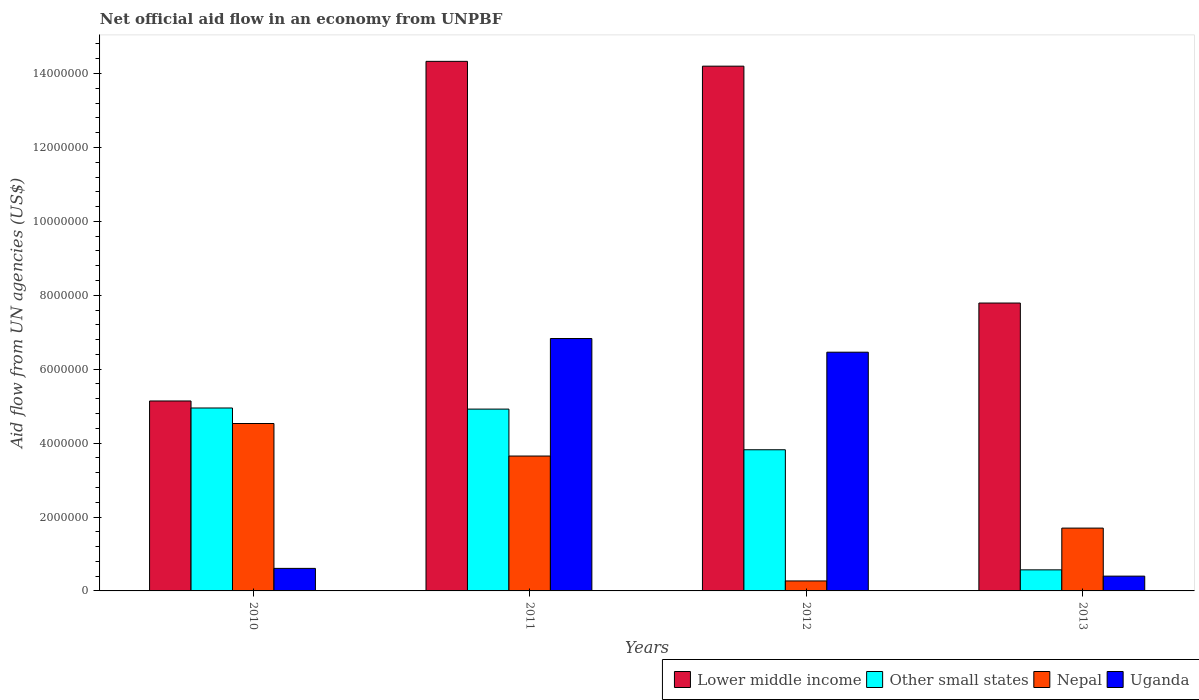How many different coloured bars are there?
Give a very brief answer. 4. How many bars are there on the 1st tick from the right?
Your answer should be very brief. 4. What is the label of the 3rd group of bars from the left?
Make the answer very short. 2012. In how many cases, is the number of bars for a given year not equal to the number of legend labels?
Provide a succinct answer. 0. What is the net official aid flow in Lower middle income in 2010?
Your response must be concise. 5.14e+06. Across all years, what is the maximum net official aid flow in Nepal?
Offer a very short reply. 4.53e+06. In which year was the net official aid flow in Lower middle income maximum?
Give a very brief answer. 2011. In which year was the net official aid flow in Other small states minimum?
Provide a succinct answer. 2013. What is the total net official aid flow in Other small states in the graph?
Provide a succinct answer. 1.43e+07. What is the difference between the net official aid flow in Nepal in 2011 and that in 2012?
Your answer should be very brief. 3.38e+06. What is the average net official aid flow in Uganda per year?
Provide a short and direct response. 3.58e+06. In the year 2011, what is the difference between the net official aid flow in Lower middle income and net official aid flow in Nepal?
Provide a short and direct response. 1.07e+07. In how many years, is the net official aid flow in Other small states greater than 7200000 US$?
Offer a terse response. 0. What is the ratio of the net official aid flow in Lower middle income in 2010 to that in 2012?
Give a very brief answer. 0.36. What is the difference between the highest and the second highest net official aid flow in Other small states?
Ensure brevity in your answer.  3.00e+04. What is the difference between the highest and the lowest net official aid flow in Uganda?
Your answer should be very brief. 6.43e+06. Is it the case that in every year, the sum of the net official aid flow in Lower middle income and net official aid flow in Uganda is greater than the sum of net official aid flow in Other small states and net official aid flow in Nepal?
Offer a terse response. Yes. What does the 2nd bar from the left in 2012 represents?
Your response must be concise. Other small states. What does the 3rd bar from the right in 2013 represents?
Give a very brief answer. Other small states. Is it the case that in every year, the sum of the net official aid flow in Nepal and net official aid flow in Uganda is greater than the net official aid flow in Other small states?
Your answer should be very brief. Yes. Are the values on the major ticks of Y-axis written in scientific E-notation?
Make the answer very short. No. Does the graph contain grids?
Offer a terse response. No. Where does the legend appear in the graph?
Keep it short and to the point. Bottom right. How many legend labels are there?
Provide a succinct answer. 4. What is the title of the graph?
Ensure brevity in your answer.  Net official aid flow in an economy from UNPBF. Does "Somalia" appear as one of the legend labels in the graph?
Provide a succinct answer. No. What is the label or title of the X-axis?
Your answer should be compact. Years. What is the label or title of the Y-axis?
Your answer should be compact. Aid flow from UN agencies (US$). What is the Aid flow from UN agencies (US$) of Lower middle income in 2010?
Offer a very short reply. 5.14e+06. What is the Aid flow from UN agencies (US$) in Other small states in 2010?
Ensure brevity in your answer.  4.95e+06. What is the Aid flow from UN agencies (US$) of Nepal in 2010?
Your answer should be very brief. 4.53e+06. What is the Aid flow from UN agencies (US$) of Lower middle income in 2011?
Offer a terse response. 1.43e+07. What is the Aid flow from UN agencies (US$) in Other small states in 2011?
Your answer should be compact. 4.92e+06. What is the Aid flow from UN agencies (US$) in Nepal in 2011?
Your answer should be very brief. 3.65e+06. What is the Aid flow from UN agencies (US$) of Uganda in 2011?
Provide a short and direct response. 6.83e+06. What is the Aid flow from UN agencies (US$) of Lower middle income in 2012?
Your response must be concise. 1.42e+07. What is the Aid flow from UN agencies (US$) in Other small states in 2012?
Your answer should be very brief. 3.82e+06. What is the Aid flow from UN agencies (US$) of Nepal in 2012?
Give a very brief answer. 2.70e+05. What is the Aid flow from UN agencies (US$) in Uganda in 2012?
Make the answer very short. 6.46e+06. What is the Aid flow from UN agencies (US$) of Lower middle income in 2013?
Offer a terse response. 7.79e+06. What is the Aid flow from UN agencies (US$) in Other small states in 2013?
Ensure brevity in your answer.  5.70e+05. What is the Aid flow from UN agencies (US$) in Nepal in 2013?
Your answer should be very brief. 1.70e+06. Across all years, what is the maximum Aid flow from UN agencies (US$) of Lower middle income?
Ensure brevity in your answer.  1.43e+07. Across all years, what is the maximum Aid flow from UN agencies (US$) in Other small states?
Offer a very short reply. 4.95e+06. Across all years, what is the maximum Aid flow from UN agencies (US$) of Nepal?
Ensure brevity in your answer.  4.53e+06. Across all years, what is the maximum Aid flow from UN agencies (US$) in Uganda?
Offer a very short reply. 6.83e+06. Across all years, what is the minimum Aid flow from UN agencies (US$) of Lower middle income?
Your answer should be compact. 5.14e+06. Across all years, what is the minimum Aid flow from UN agencies (US$) of Other small states?
Offer a very short reply. 5.70e+05. Across all years, what is the minimum Aid flow from UN agencies (US$) of Nepal?
Your answer should be very brief. 2.70e+05. Across all years, what is the minimum Aid flow from UN agencies (US$) in Uganda?
Keep it short and to the point. 4.00e+05. What is the total Aid flow from UN agencies (US$) of Lower middle income in the graph?
Your answer should be very brief. 4.15e+07. What is the total Aid flow from UN agencies (US$) of Other small states in the graph?
Provide a short and direct response. 1.43e+07. What is the total Aid flow from UN agencies (US$) of Nepal in the graph?
Provide a succinct answer. 1.02e+07. What is the total Aid flow from UN agencies (US$) of Uganda in the graph?
Your answer should be very brief. 1.43e+07. What is the difference between the Aid flow from UN agencies (US$) of Lower middle income in 2010 and that in 2011?
Offer a very short reply. -9.19e+06. What is the difference between the Aid flow from UN agencies (US$) in Nepal in 2010 and that in 2011?
Your answer should be compact. 8.80e+05. What is the difference between the Aid flow from UN agencies (US$) of Uganda in 2010 and that in 2011?
Make the answer very short. -6.22e+06. What is the difference between the Aid flow from UN agencies (US$) of Lower middle income in 2010 and that in 2012?
Your answer should be compact. -9.06e+06. What is the difference between the Aid flow from UN agencies (US$) in Other small states in 2010 and that in 2012?
Provide a succinct answer. 1.13e+06. What is the difference between the Aid flow from UN agencies (US$) in Nepal in 2010 and that in 2012?
Your response must be concise. 4.26e+06. What is the difference between the Aid flow from UN agencies (US$) in Uganda in 2010 and that in 2012?
Your response must be concise. -5.85e+06. What is the difference between the Aid flow from UN agencies (US$) in Lower middle income in 2010 and that in 2013?
Your answer should be compact. -2.65e+06. What is the difference between the Aid flow from UN agencies (US$) in Other small states in 2010 and that in 2013?
Offer a terse response. 4.38e+06. What is the difference between the Aid flow from UN agencies (US$) of Nepal in 2010 and that in 2013?
Ensure brevity in your answer.  2.83e+06. What is the difference between the Aid flow from UN agencies (US$) of Uganda in 2010 and that in 2013?
Provide a short and direct response. 2.10e+05. What is the difference between the Aid flow from UN agencies (US$) in Lower middle income in 2011 and that in 2012?
Make the answer very short. 1.30e+05. What is the difference between the Aid flow from UN agencies (US$) in Other small states in 2011 and that in 2012?
Your answer should be compact. 1.10e+06. What is the difference between the Aid flow from UN agencies (US$) in Nepal in 2011 and that in 2012?
Ensure brevity in your answer.  3.38e+06. What is the difference between the Aid flow from UN agencies (US$) in Lower middle income in 2011 and that in 2013?
Your answer should be very brief. 6.54e+06. What is the difference between the Aid flow from UN agencies (US$) in Other small states in 2011 and that in 2013?
Your response must be concise. 4.35e+06. What is the difference between the Aid flow from UN agencies (US$) of Nepal in 2011 and that in 2013?
Make the answer very short. 1.95e+06. What is the difference between the Aid flow from UN agencies (US$) of Uganda in 2011 and that in 2013?
Give a very brief answer. 6.43e+06. What is the difference between the Aid flow from UN agencies (US$) of Lower middle income in 2012 and that in 2013?
Your answer should be very brief. 6.41e+06. What is the difference between the Aid flow from UN agencies (US$) of Other small states in 2012 and that in 2013?
Your answer should be compact. 3.25e+06. What is the difference between the Aid flow from UN agencies (US$) in Nepal in 2012 and that in 2013?
Offer a terse response. -1.43e+06. What is the difference between the Aid flow from UN agencies (US$) of Uganda in 2012 and that in 2013?
Ensure brevity in your answer.  6.06e+06. What is the difference between the Aid flow from UN agencies (US$) in Lower middle income in 2010 and the Aid flow from UN agencies (US$) in Nepal in 2011?
Keep it short and to the point. 1.49e+06. What is the difference between the Aid flow from UN agencies (US$) in Lower middle income in 2010 and the Aid flow from UN agencies (US$) in Uganda in 2011?
Ensure brevity in your answer.  -1.69e+06. What is the difference between the Aid flow from UN agencies (US$) in Other small states in 2010 and the Aid flow from UN agencies (US$) in Nepal in 2011?
Provide a short and direct response. 1.30e+06. What is the difference between the Aid flow from UN agencies (US$) of Other small states in 2010 and the Aid flow from UN agencies (US$) of Uganda in 2011?
Your response must be concise. -1.88e+06. What is the difference between the Aid flow from UN agencies (US$) in Nepal in 2010 and the Aid flow from UN agencies (US$) in Uganda in 2011?
Offer a very short reply. -2.30e+06. What is the difference between the Aid flow from UN agencies (US$) of Lower middle income in 2010 and the Aid flow from UN agencies (US$) of Other small states in 2012?
Make the answer very short. 1.32e+06. What is the difference between the Aid flow from UN agencies (US$) of Lower middle income in 2010 and the Aid flow from UN agencies (US$) of Nepal in 2012?
Keep it short and to the point. 4.87e+06. What is the difference between the Aid flow from UN agencies (US$) in Lower middle income in 2010 and the Aid flow from UN agencies (US$) in Uganda in 2012?
Your response must be concise. -1.32e+06. What is the difference between the Aid flow from UN agencies (US$) in Other small states in 2010 and the Aid flow from UN agencies (US$) in Nepal in 2012?
Your answer should be compact. 4.68e+06. What is the difference between the Aid flow from UN agencies (US$) of Other small states in 2010 and the Aid flow from UN agencies (US$) of Uganda in 2012?
Provide a short and direct response. -1.51e+06. What is the difference between the Aid flow from UN agencies (US$) of Nepal in 2010 and the Aid flow from UN agencies (US$) of Uganda in 2012?
Provide a short and direct response. -1.93e+06. What is the difference between the Aid flow from UN agencies (US$) in Lower middle income in 2010 and the Aid flow from UN agencies (US$) in Other small states in 2013?
Offer a very short reply. 4.57e+06. What is the difference between the Aid flow from UN agencies (US$) of Lower middle income in 2010 and the Aid flow from UN agencies (US$) of Nepal in 2013?
Offer a very short reply. 3.44e+06. What is the difference between the Aid flow from UN agencies (US$) of Lower middle income in 2010 and the Aid flow from UN agencies (US$) of Uganda in 2013?
Your answer should be very brief. 4.74e+06. What is the difference between the Aid flow from UN agencies (US$) of Other small states in 2010 and the Aid flow from UN agencies (US$) of Nepal in 2013?
Ensure brevity in your answer.  3.25e+06. What is the difference between the Aid flow from UN agencies (US$) of Other small states in 2010 and the Aid flow from UN agencies (US$) of Uganda in 2013?
Offer a very short reply. 4.55e+06. What is the difference between the Aid flow from UN agencies (US$) of Nepal in 2010 and the Aid flow from UN agencies (US$) of Uganda in 2013?
Provide a short and direct response. 4.13e+06. What is the difference between the Aid flow from UN agencies (US$) in Lower middle income in 2011 and the Aid flow from UN agencies (US$) in Other small states in 2012?
Your answer should be compact. 1.05e+07. What is the difference between the Aid flow from UN agencies (US$) of Lower middle income in 2011 and the Aid flow from UN agencies (US$) of Nepal in 2012?
Give a very brief answer. 1.41e+07. What is the difference between the Aid flow from UN agencies (US$) of Lower middle income in 2011 and the Aid flow from UN agencies (US$) of Uganda in 2012?
Provide a succinct answer. 7.87e+06. What is the difference between the Aid flow from UN agencies (US$) in Other small states in 2011 and the Aid flow from UN agencies (US$) in Nepal in 2012?
Provide a succinct answer. 4.65e+06. What is the difference between the Aid flow from UN agencies (US$) in Other small states in 2011 and the Aid flow from UN agencies (US$) in Uganda in 2012?
Provide a short and direct response. -1.54e+06. What is the difference between the Aid flow from UN agencies (US$) in Nepal in 2011 and the Aid flow from UN agencies (US$) in Uganda in 2012?
Your answer should be very brief. -2.81e+06. What is the difference between the Aid flow from UN agencies (US$) in Lower middle income in 2011 and the Aid flow from UN agencies (US$) in Other small states in 2013?
Offer a terse response. 1.38e+07. What is the difference between the Aid flow from UN agencies (US$) of Lower middle income in 2011 and the Aid flow from UN agencies (US$) of Nepal in 2013?
Offer a very short reply. 1.26e+07. What is the difference between the Aid flow from UN agencies (US$) in Lower middle income in 2011 and the Aid flow from UN agencies (US$) in Uganda in 2013?
Offer a very short reply. 1.39e+07. What is the difference between the Aid flow from UN agencies (US$) of Other small states in 2011 and the Aid flow from UN agencies (US$) of Nepal in 2013?
Offer a terse response. 3.22e+06. What is the difference between the Aid flow from UN agencies (US$) in Other small states in 2011 and the Aid flow from UN agencies (US$) in Uganda in 2013?
Your response must be concise. 4.52e+06. What is the difference between the Aid flow from UN agencies (US$) of Nepal in 2011 and the Aid flow from UN agencies (US$) of Uganda in 2013?
Provide a short and direct response. 3.25e+06. What is the difference between the Aid flow from UN agencies (US$) in Lower middle income in 2012 and the Aid flow from UN agencies (US$) in Other small states in 2013?
Your answer should be compact. 1.36e+07. What is the difference between the Aid flow from UN agencies (US$) of Lower middle income in 2012 and the Aid flow from UN agencies (US$) of Nepal in 2013?
Your answer should be compact. 1.25e+07. What is the difference between the Aid flow from UN agencies (US$) in Lower middle income in 2012 and the Aid flow from UN agencies (US$) in Uganda in 2013?
Your answer should be compact. 1.38e+07. What is the difference between the Aid flow from UN agencies (US$) in Other small states in 2012 and the Aid flow from UN agencies (US$) in Nepal in 2013?
Offer a very short reply. 2.12e+06. What is the difference between the Aid flow from UN agencies (US$) of Other small states in 2012 and the Aid flow from UN agencies (US$) of Uganda in 2013?
Offer a terse response. 3.42e+06. What is the average Aid flow from UN agencies (US$) in Lower middle income per year?
Make the answer very short. 1.04e+07. What is the average Aid flow from UN agencies (US$) of Other small states per year?
Your response must be concise. 3.56e+06. What is the average Aid flow from UN agencies (US$) of Nepal per year?
Keep it short and to the point. 2.54e+06. What is the average Aid flow from UN agencies (US$) in Uganda per year?
Your answer should be very brief. 3.58e+06. In the year 2010, what is the difference between the Aid flow from UN agencies (US$) in Lower middle income and Aid flow from UN agencies (US$) in Other small states?
Your answer should be very brief. 1.90e+05. In the year 2010, what is the difference between the Aid flow from UN agencies (US$) of Lower middle income and Aid flow from UN agencies (US$) of Nepal?
Make the answer very short. 6.10e+05. In the year 2010, what is the difference between the Aid flow from UN agencies (US$) in Lower middle income and Aid flow from UN agencies (US$) in Uganda?
Your answer should be compact. 4.53e+06. In the year 2010, what is the difference between the Aid flow from UN agencies (US$) of Other small states and Aid flow from UN agencies (US$) of Uganda?
Provide a succinct answer. 4.34e+06. In the year 2010, what is the difference between the Aid flow from UN agencies (US$) of Nepal and Aid flow from UN agencies (US$) of Uganda?
Make the answer very short. 3.92e+06. In the year 2011, what is the difference between the Aid flow from UN agencies (US$) in Lower middle income and Aid flow from UN agencies (US$) in Other small states?
Provide a succinct answer. 9.41e+06. In the year 2011, what is the difference between the Aid flow from UN agencies (US$) of Lower middle income and Aid flow from UN agencies (US$) of Nepal?
Your response must be concise. 1.07e+07. In the year 2011, what is the difference between the Aid flow from UN agencies (US$) in Lower middle income and Aid flow from UN agencies (US$) in Uganda?
Keep it short and to the point. 7.50e+06. In the year 2011, what is the difference between the Aid flow from UN agencies (US$) of Other small states and Aid flow from UN agencies (US$) of Nepal?
Keep it short and to the point. 1.27e+06. In the year 2011, what is the difference between the Aid flow from UN agencies (US$) in Other small states and Aid flow from UN agencies (US$) in Uganda?
Your answer should be very brief. -1.91e+06. In the year 2011, what is the difference between the Aid flow from UN agencies (US$) of Nepal and Aid flow from UN agencies (US$) of Uganda?
Provide a short and direct response. -3.18e+06. In the year 2012, what is the difference between the Aid flow from UN agencies (US$) in Lower middle income and Aid flow from UN agencies (US$) in Other small states?
Ensure brevity in your answer.  1.04e+07. In the year 2012, what is the difference between the Aid flow from UN agencies (US$) in Lower middle income and Aid flow from UN agencies (US$) in Nepal?
Keep it short and to the point. 1.39e+07. In the year 2012, what is the difference between the Aid flow from UN agencies (US$) of Lower middle income and Aid flow from UN agencies (US$) of Uganda?
Give a very brief answer. 7.74e+06. In the year 2012, what is the difference between the Aid flow from UN agencies (US$) in Other small states and Aid flow from UN agencies (US$) in Nepal?
Provide a succinct answer. 3.55e+06. In the year 2012, what is the difference between the Aid flow from UN agencies (US$) in Other small states and Aid flow from UN agencies (US$) in Uganda?
Give a very brief answer. -2.64e+06. In the year 2012, what is the difference between the Aid flow from UN agencies (US$) in Nepal and Aid flow from UN agencies (US$) in Uganda?
Your answer should be compact. -6.19e+06. In the year 2013, what is the difference between the Aid flow from UN agencies (US$) of Lower middle income and Aid flow from UN agencies (US$) of Other small states?
Your answer should be compact. 7.22e+06. In the year 2013, what is the difference between the Aid flow from UN agencies (US$) in Lower middle income and Aid flow from UN agencies (US$) in Nepal?
Your response must be concise. 6.09e+06. In the year 2013, what is the difference between the Aid flow from UN agencies (US$) in Lower middle income and Aid flow from UN agencies (US$) in Uganda?
Provide a succinct answer. 7.39e+06. In the year 2013, what is the difference between the Aid flow from UN agencies (US$) of Other small states and Aid flow from UN agencies (US$) of Nepal?
Keep it short and to the point. -1.13e+06. In the year 2013, what is the difference between the Aid flow from UN agencies (US$) of Other small states and Aid flow from UN agencies (US$) of Uganda?
Provide a succinct answer. 1.70e+05. In the year 2013, what is the difference between the Aid flow from UN agencies (US$) of Nepal and Aid flow from UN agencies (US$) of Uganda?
Provide a succinct answer. 1.30e+06. What is the ratio of the Aid flow from UN agencies (US$) in Lower middle income in 2010 to that in 2011?
Offer a terse response. 0.36. What is the ratio of the Aid flow from UN agencies (US$) in Nepal in 2010 to that in 2011?
Provide a short and direct response. 1.24. What is the ratio of the Aid flow from UN agencies (US$) of Uganda in 2010 to that in 2011?
Provide a short and direct response. 0.09. What is the ratio of the Aid flow from UN agencies (US$) in Lower middle income in 2010 to that in 2012?
Provide a short and direct response. 0.36. What is the ratio of the Aid flow from UN agencies (US$) of Other small states in 2010 to that in 2012?
Ensure brevity in your answer.  1.3. What is the ratio of the Aid flow from UN agencies (US$) in Nepal in 2010 to that in 2012?
Provide a succinct answer. 16.78. What is the ratio of the Aid flow from UN agencies (US$) in Uganda in 2010 to that in 2012?
Offer a very short reply. 0.09. What is the ratio of the Aid flow from UN agencies (US$) in Lower middle income in 2010 to that in 2013?
Make the answer very short. 0.66. What is the ratio of the Aid flow from UN agencies (US$) in Other small states in 2010 to that in 2013?
Ensure brevity in your answer.  8.68. What is the ratio of the Aid flow from UN agencies (US$) in Nepal in 2010 to that in 2013?
Your response must be concise. 2.66. What is the ratio of the Aid flow from UN agencies (US$) in Uganda in 2010 to that in 2013?
Make the answer very short. 1.52. What is the ratio of the Aid flow from UN agencies (US$) of Lower middle income in 2011 to that in 2012?
Give a very brief answer. 1.01. What is the ratio of the Aid flow from UN agencies (US$) of Other small states in 2011 to that in 2012?
Give a very brief answer. 1.29. What is the ratio of the Aid flow from UN agencies (US$) of Nepal in 2011 to that in 2012?
Ensure brevity in your answer.  13.52. What is the ratio of the Aid flow from UN agencies (US$) in Uganda in 2011 to that in 2012?
Offer a very short reply. 1.06. What is the ratio of the Aid flow from UN agencies (US$) of Lower middle income in 2011 to that in 2013?
Give a very brief answer. 1.84. What is the ratio of the Aid flow from UN agencies (US$) of Other small states in 2011 to that in 2013?
Keep it short and to the point. 8.63. What is the ratio of the Aid flow from UN agencies (US$) in Nepal in 2011 to that in 2013?
Provide a short and direct response. 2.15. What is the ratio of the Aid flow from UN agencies (US$) in Uganda in 2011 to that in 2013?
Your answer should be very brief. 17.07. What is the ratio of the Aid flow from UN agencies (US$) in Lower middle income in 2012 to that in 2013?
Offer a terse response. 1.82. What is the ratio of the Aid flow from UN agencies (US$) in Other small states in 2012 to that in 2013?
Keep it short and to the point. 6.7. What is the ratio of the Aid flow from UN agencies (US$) in Nepal in 2012 to that in 2013?
Your response must be concise. 0.16. What is the ratio of the Aid flow from UN agencies (US$) in Uganda in 2012 to that in 2013?
Give a very brief answer. 16.15. What is the difference between the highest and the second highest Aid flow from UN agencies (US$) of Lower middle income?
Your response must be concise. 1.30e+05. What is the difference between the highest and the second highest Aid flow from UN agencies (US$) in Other small states?
Offer a terse response. 3.00e+04. What is the difference between the highest and the second highest Aid flow from UN agencies (US$) in Nepal?
Offer a very short reply. 8.80e+05. What is the difference between the highest and the lowest Aid flow from UN agencies (US$) in Lower middle income?
Give a very brief answer. 9.19e+06. What is the difference between the highest and the lowest Aid flow from UN agencies (US$) of Other small states?
Your answer should be very brief. 4.38e+06. What is the difference between the highest and the lowest Aid flow from UN agencies (US$) of Nepal?
Keep it short and to the point. 4.26e+06. What is the difference between the highest and the lowest Aid flow from UN agencies (US$) of Uganda?
Make the answer very short. 6.43e+06. 